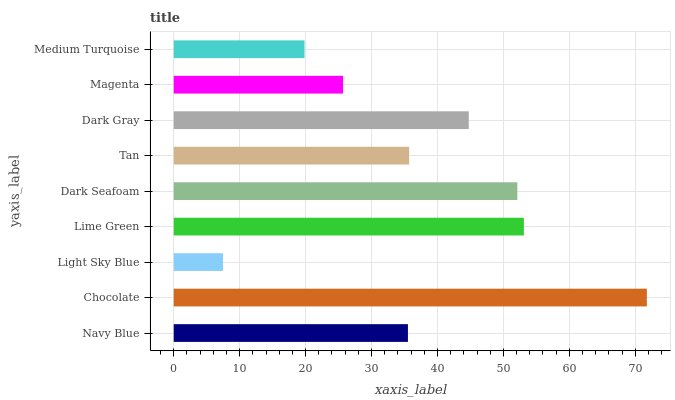Is Light Sky Blue the minimum?
Answer yes or no. Yes. Is Chocolate the maximum?
Answer yes or no. Yes. Is Chocolate the minimum?
Answer yes or no. No. Is Light Sky Blue the maximum?
Answer yes or no. No. Is Chocolate greater than Light Sky Blue?
Answer yes or no. Yes. Is Light Sky Blue less than Chocolate?
Answer yes or no. Yes. Is Light Sky Blue greater than Chocolate?
Answer yes or no. No. Is Chocolate less than Light Sky Blue?
Answer yes or no. No. Is Tan the high median?
Answer yes or no. Yes. Is Tan the low median?
Answer yes or no. Yes. Is Navy Blue the high median?
Answer yes or no. No. Is Chocolate the low median?
Answer yes or no. No. 